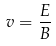<formula> <loc_0><loc_0><loc_500><loc_500>v = { \frac { E } { B } }</formula> 